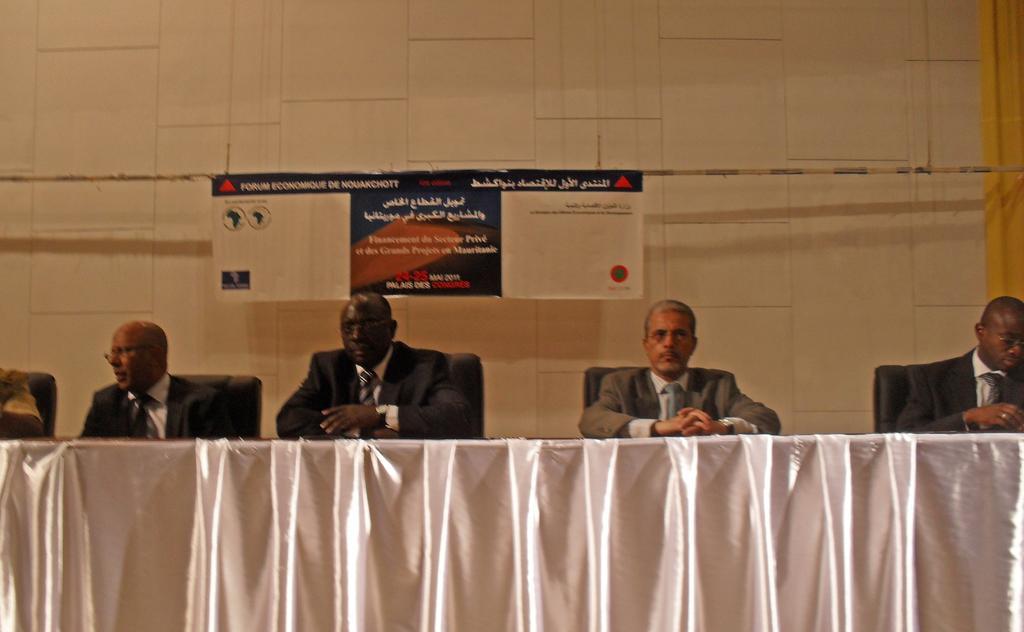Can you describe this image briefly? In this image I can see the group of people sitting on the chairs and wearing the blazers. In-front of these people I can see the table covered with cloth. In the background I can see the board and the wall. 